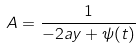Convert formula to latex. <formula><loc_0><loc_0><loc_500><loc_500>A = \frac { 1 } { - 2 a y + \psi ( t ) }</formula> 